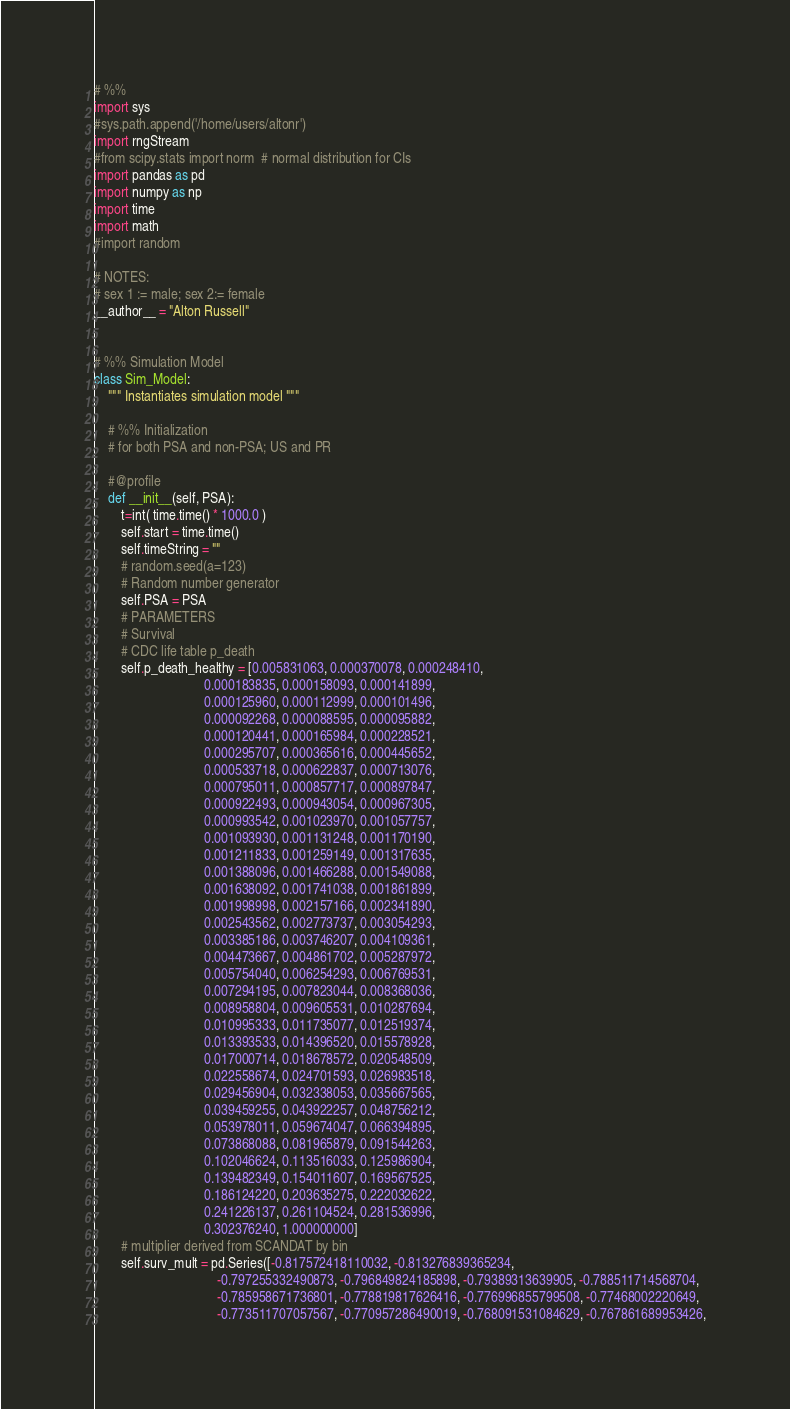<code> <loc_0><loc_0><loc_500><loc_500><_Python_># %%
import sys
#sys.path.append('/home/users/altonr')
import rngStream
#from scipy.stats import norm  # normal distribution for CIs
import pandas as pd
import numpy as np
import time
import math
#import random

# NOTES:
# sex 1 := male; sex 2:= female
__author__ = "Alton Russell"


# %% Simulation Model
class Sim_Model:
    """ Instantiates simulation model """

    # %% Initialization
    # for both PSA and non-PSA; US and PR

    #@profile
    def __init__(self, PSA):
        t=int( time.time() * 1000.0 )
        self.start = time.time()
        self.timeString = ""
        # random.seed(a=123)
        # Random number generator      
        self.PSA = PSA
        # PARAMETERS
        # Survival
        # CDC life table p_death
        self.p_death_healthy = [0.005831063, 0.000370078, 0.000248410,
                                0.000183835, 0.000158093, 0.000141899,
                                0.000125960, 0.000112999, 0.000101496,
                                0.000092268, 0.000088595, 0.000095882,
                                0.000120441, 0.000165984, 0.000228521,
                                0.000295707, 0.000365616, 0.000445652,
                                0.000533718, 0.000622837, 0.000713076,
                                0.000795011, 0.000857717, 0.000897847,
                                0.000922493, 0.000943054, 0.000967305,
                                0.000993542, 0.001023970, 0.001057757,
                                0.001093930, 0.001131248, 0.001170190,
                                0.001211833, 0.001259149, 0.001317635,
                                0.001388096, 0.001466288, 0.001549088,
                                0.001638092, 0.001741038, 0.001861899,
                                0.001998998, 0.002157166, 0.002341890,
                                0.002543562, 0.002773737, 0.003054293,
                                0.003385186, 0.003746207, 0.004109361,
                                0.004473667, 0.004861702, 0.005287972,
                                0.005754040, 0.006254293, 0.006769531,
                                0.007294195, 0.007823044, 0.008368036,
                                0.008958804, 0.009605531, 0.010287694,
                                0.010995333, 0.011735077, 0.012519374,
                                0.013393533, 0.014396520, 0.015578928,
                                0.017000714, 0.018678572, 0.020548509,
                                0.022558674, 0.024701593, 0.026983518,
                                0.029456904, 0.032338053, 0.035667565,
                                0.039459255, 0.043922257, 0.048756212,
                                0.053978011, 0.059674047, 0.066394895,
                                0.073868088, 0.081965879, 0.091544263,
                                0.102046624, 0.113516033, 0.125986904,
                                0.139482349, 0.154011607, 0.169567525,
                                0.186124220, 0.203635275, 0.222032622,
                                0.241226137, 0.261104524, 0.281536996,
                                0.302376240, 1.000000000]
        # multiplier derived from SCANDAT by bin
        self.surv_mult = pd.Series([-0.817572418110032, -0.813276839365234,
                                    -0.797255332490873, -0.796849824185898, -0.79389313639905, -0.788511714568704,
                                    -0.785958671736801, -0.778819817626416, -0.776996855799508, -0.77468002220649,
                                    -0.773511707057567, -0.770957286490019, -0.768091531084629, -0.767861689953426,</code> 